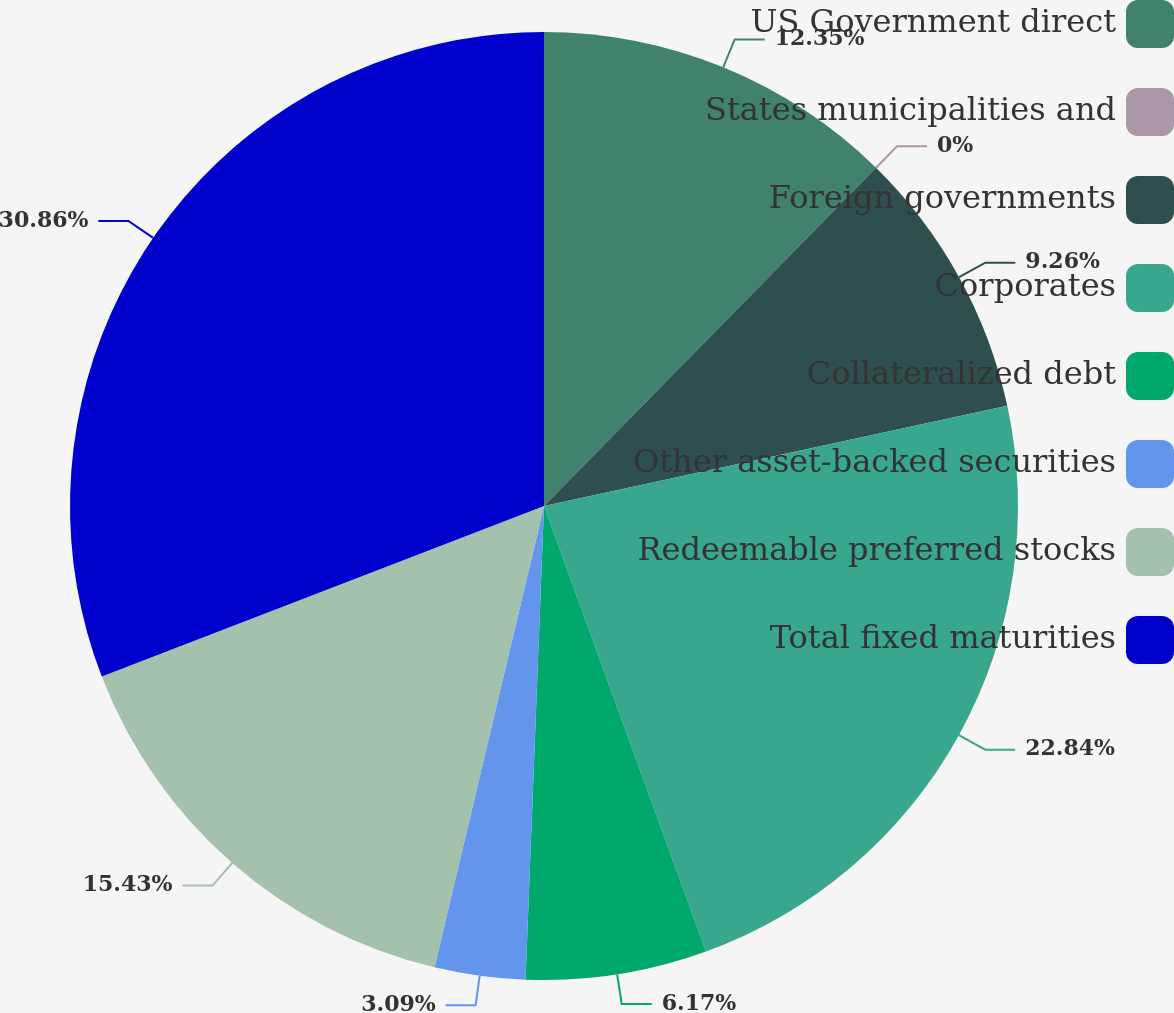<chart> <loc_0><loc_0><loc_500><loc_500><pie_chart><fcel>US Government direct<fcel>States municipalities and<fcel>Foreign governments<fcel>Corporates<fcel>Collateralized debt<fcel>Other asset-backed securities<fcel>Redeemable preferred stocks<fcel>Total fixed maturities<nl><fcel>12.35%<fcel>0.0%<fcel>9.26%<fcel>22.84%<fcel>6.17%<fcel>3.09%<fcel>15.43%<fcel>30.86%<nl></chart> 